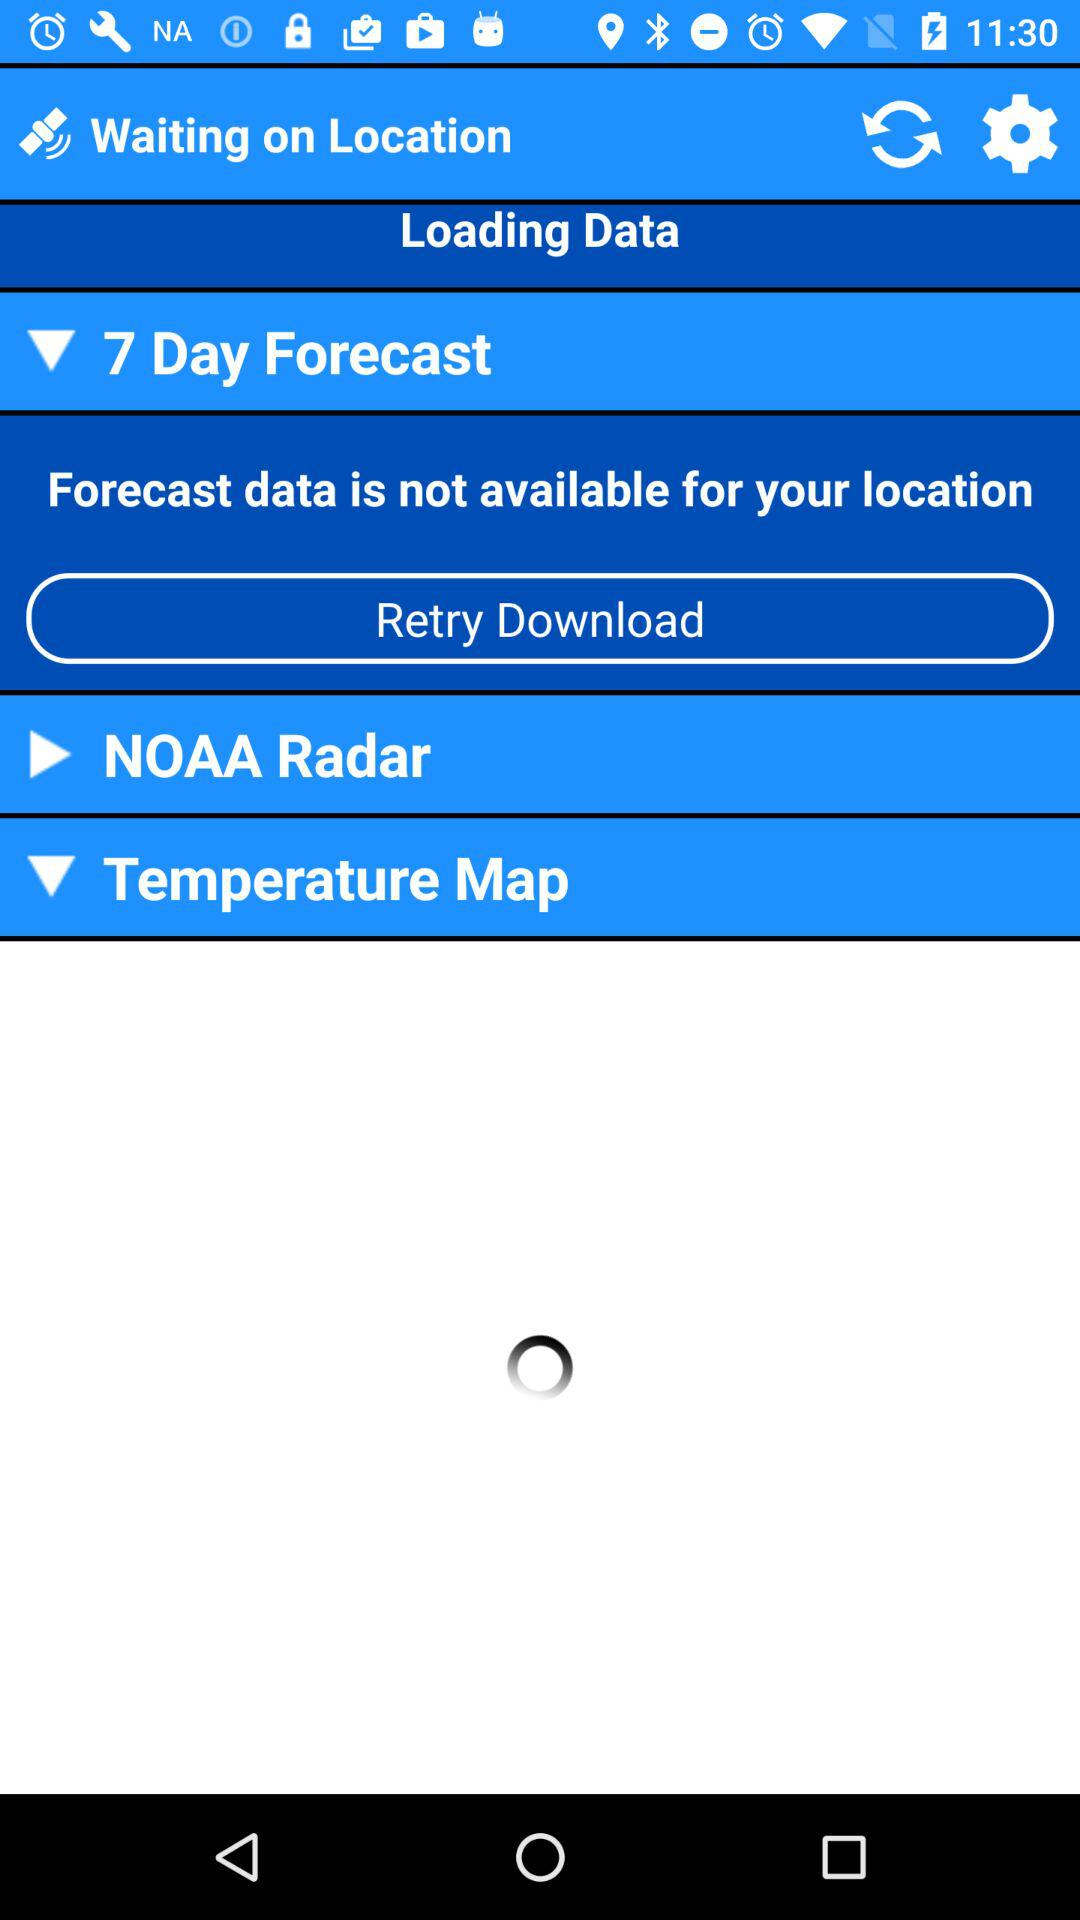Is the forecast data available for my location? The forecast data is not available for your location. 